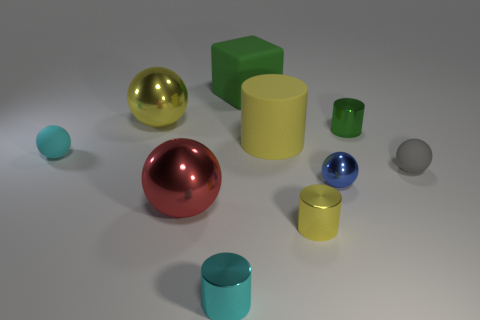What are the different colors of spheres present in the image? The image features spheres in red, gold, blue, and one that appears to be gray or silver. 